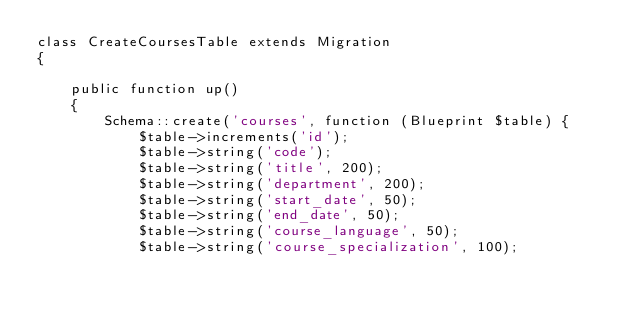<code> <loc_0><loc_0><loc_500><loc_500><_PHP_>class CreateCoursesTable extends Migration
{

    public function up()
    {
        Schema::create('courses', function (Blueprint $table) {
            $table->increments('id');
            $table->string('code');
            $table->string('title', 200);
            $table->string('department', 200);
            $table->string('start_date', 50);
            $table->string('end_date', 50);
            $table->string('course_language', 50);
            $table->string('course_specialization', 100);</code> 